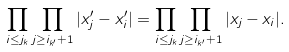Convert formula to latex. <formula><loc_0><loc_0><loc_500><loc_500>\prod _ { i \leq j _ { k } } \prod _ { j \geq i _ { k ^ { \prime } } + 1 } | x _ { j } ^ { \prime } - x _ { i } ^ { \prime } | = \prod _ { i \leq j _ { k } } \prod _ { j \geq i _ { k ^ { \prime } } + 1 } | x _ { j } - x _ { i } | .</formula> 